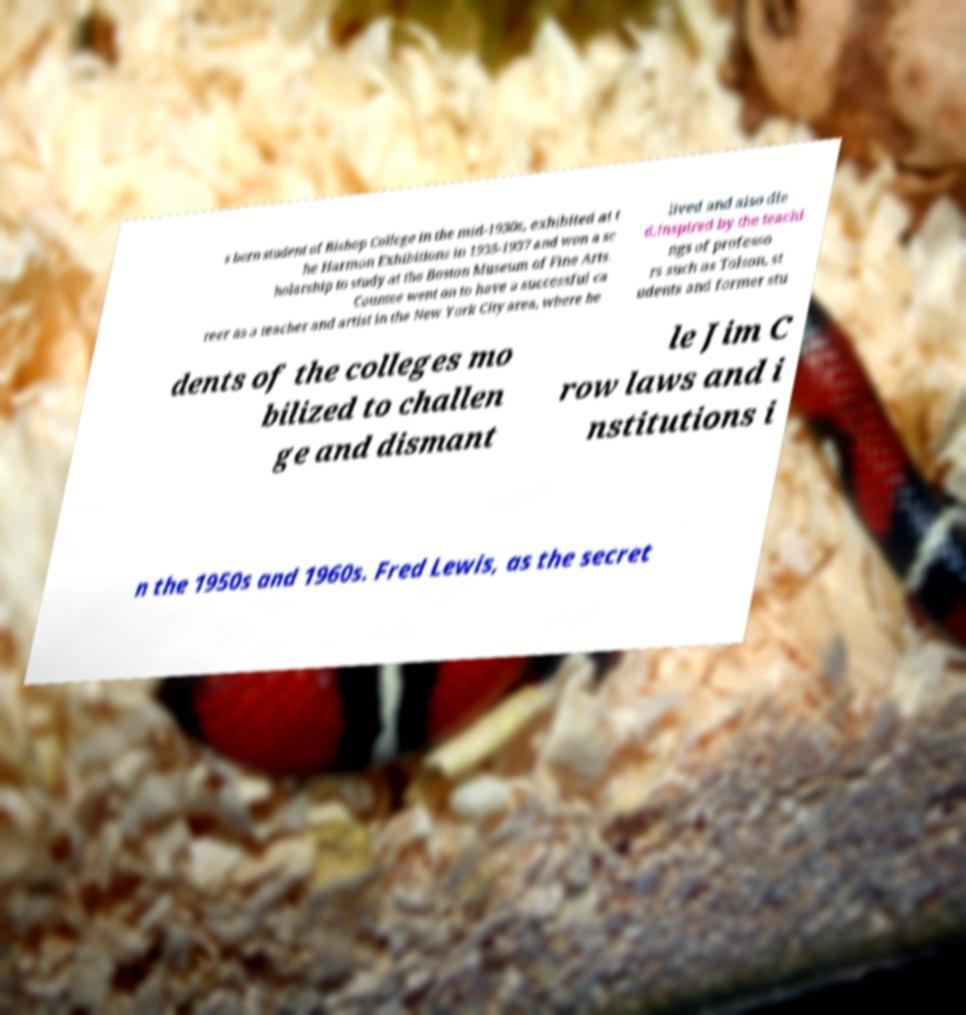Can you accurately transcribe the text from the provided image for me? s born student of Bishop College in the mid-1930s, exhibited at t he Harmon Exhibitions in 1935-1937 and won a sc holarship to study at the Boston Museum of Fine Arts. Countee went on to have a successful ca reer as a teacher and artist in the New York City area, where he lived and also die d.Inspired by the teachi ngs of professo rs such as Tolson, st udents and former stu dents of the colleges mo bilized to challen ge and dismant le Jim C row laws and i nstitutions i n the 1950s and 1960s. Fred Lewis, as the secret 